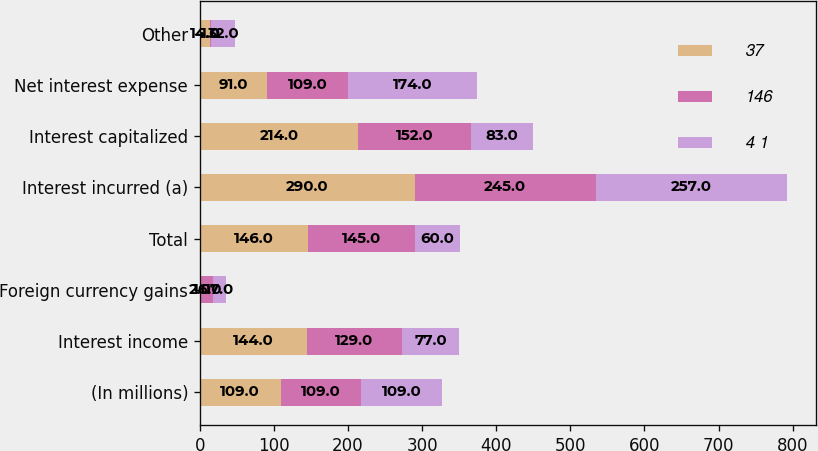Convert chart to OTSL. <chart><loc_0><loc_0><loc_500><loc_500><stacked_bar_chart><ecel><fcel>(In millions)<fcel>Interest income<fcel>Foreign currency gains<fcel>Total<fcel>Interest incurred (a)<fcel>Interest capitalized<fcel>Net interest expense<fcel>Other<nl><fcel>37<fcel>109<fcel>144<fcel>2<fcel>146<fcel>290<fcel>214<fcel>91<fcel>14<nl><fcel>146<fcel>109<fcel>129<fcel>16<fcel>145<fcel>245<fcel>152<fcel>109<fcel>1<nl><fcel>4 1<fcel>109<fcel>77<fcel>17<fcel>60<fcel>257<fcel>83<fcel>174<fcel>32<nl></chart> 